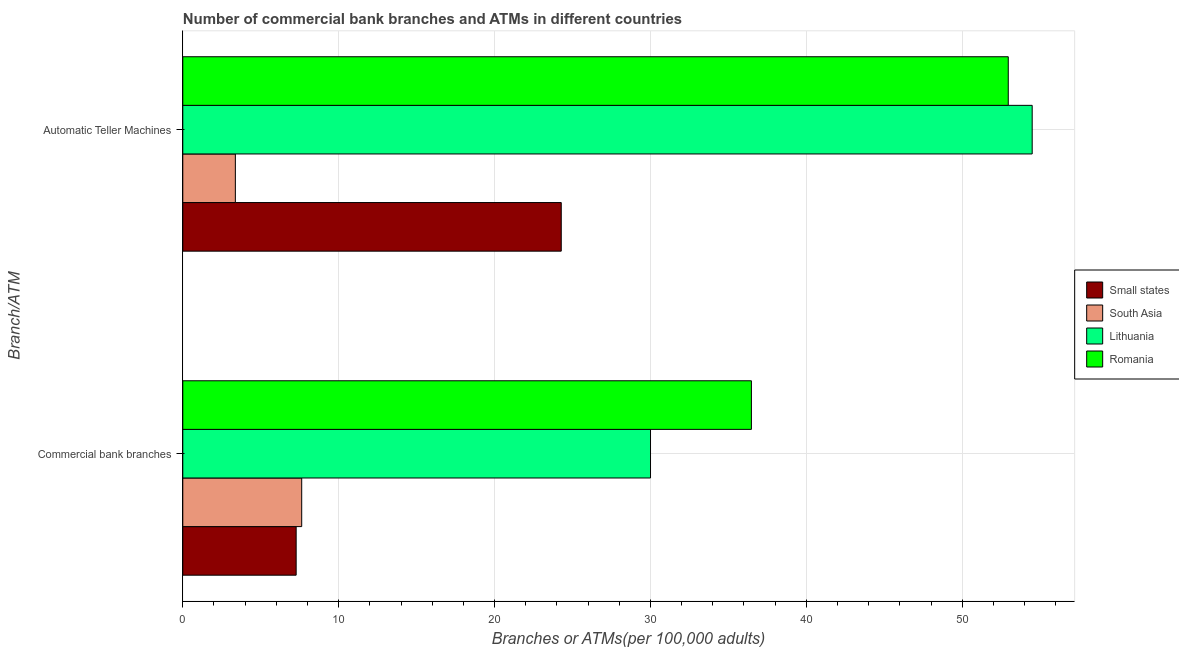How many groups of bars are there?
Make the answer very short. 2. Are the number of bars per tick equal to the number of legend labels?
Offer a very short reply. Yes. Are the number of bars on each tick of the Y-axis equal?
Offer a terse response. Yes. How many bars are there on the 2nd tick from the top?
Offer a terse response. 4. How many bars are there on the 2nd tick from the bottom?
Offer a terse response. 4. What is the label of the 1st group of bars from the top?
Offer a very short reply. Automatic Teller Machines. What is the number of commercal bank branches in Small states?
Make the answer very short. 7.27. Across all countries, what is the maximum number of atms?
Offer a very short reply. 54.49. Across all countries, what is the minimum number of commercal bank branches?
Your response must be concise. 7.27. In which country was the number of commercal bank branches maximum?
Offer a terse response. Romania. In which country was the number of atms minimum?
Provide a short and direct response. South Asia. What is the total number of commercal bank branches in the graph?
Provide a succinct answer. 81.38. What is the difference between the number of commercal bank branches in Small states and that in South Asia?
Your answer should be very brief. -0.36. What is the difference between the number of atms in South Asia and the number of commercal bank branches in Romania?
Your answer should be very brief. -33.1. What is the average number of atms per country?
Provide a short and direct response. 33.77. What is the difference between the number of atms and number of commercal bank branches in Small states?
Your response must be concise. 17. In how many countries, is the number of atms greater than 26 ?
Provide a succinct answer. 2. What is the ratio of the number of commercal bank branches in Lithuania to that in Small states?
Your answer should be very brief. 4.13. Is the number of commercal bank branches in Small states less than that in South Asia?
Your response must be concise. Yes. In how many countries, is the number of atms greater than the average number of atms taken over all countries?
Give a very brief answer. 2. What does the 1st bar from the top in Commercial bank branches represents?
Provide a short and direct response. Romania. What does the 2nd bar from the bottom in Commercial bank branches represents?
Your answer should be compact. South Asia. How many bars are there?
Give a very brief answer. 8. Are all the bars in the graph horizontal?
Give a very brief answer. Yes. What is the difference between two consecutive major ticks on the X-axis?
Offer a very short reply. 10. Are the values on the major ticks of X-axis written in scientific E-notation?
Ensure brevity in your answer.  No. Where does the legend appear in the graph?
Make the answer very short. Center right. How are the legend labels stacked?
Keep it short and to the point. Vertical. What is the title of the graph?
Offer a very short reply. Number of commercial bank branches and ATMs in different countries. What is the label or title of the X-axis?
Keep it short and to the point. Branches or ATMs(per 100,0 adults). What is the label or title of the Y-axis?
Provide a succinct answer. Branch/ATM. What is the Branches or ATMs(per 100,000 adults) of Small states in Commercial bank branches?
Offer a terse response. 7.27. What is the Branches or ATMs(per 100,000 adults) in South Asia in Commercial bank branches?
Your answer should be very brief. 7.63. What is the Branches or ATMs(per 100,000 adults) of Lithuania in Commercial bank branches?
Ensure brevity in your answer.  30. What is the Branches or ATMs(per 100,000 adults) of Romania in Commercial bank branches?
Offer a terse response. 36.48. What is the Branches or ATMs(per 100,000 adults) in Small states in Automatic Teller Machines?
Provide a short and direct response. 24.28. What is the Branches or ATMs(per 100,000 adults) in South Asia in Automatic Teller Machines?
Provide a succinct answer. 3.37. What is the Branches or ATMs(per 100,000 adults) in Lithuania in Automatic Teller Machines?
Keep it short and to the point. 54.49. What is the Branches or ATMs(per 100,000 adults) of Romania in Automatic Teller Machines?
Your answer should be compact. 52.95. Across all Branch/ATM, what is the maximum Branches or ATMs(per 100,000 adults) of Small states?
Keep it short and to the point. 24.28. Across all Branch/ATM, what is the maximum Branches or ATMs(per 100,000 adults) of South Asia?
Your response must be concise. 7.63. Across all Branch/ATM, what is the maximum Branches or ATMs(per 100,000 adults) of Lithuania?
Provide a short and direct response. 54.49. Across all Branch/ATM, what is the maximum Branches or ATMs(per 100,000 adults) in Romania?
Ensure brevity in your answer.  52.95. Across all Branch/ATM, what is the minimum Branches or ATMs(per 100,000 adults) of Small states?
Ensure brevity in your answer.  7.27. Across all Branch/ATM, what is the minimum Branches or ATMs(per 100,000 adults) of South Asia?
Provide a succinct answer. 3.37. Across all Branch/ATM, what is the minimum Branches or ATMs(per 100,000 adults) in Lithuania?
Your response must be concise. 30. Across all Branch/ATM, what is the minimum Branches or ATMs(per 100,000 adults) of Romania?
Make the answer very short. 36.48. What is the total Branches or ATMs(per 100,000 adults) in Small states in the graph?
Offer a very short reply. 31.55. What is the total Branches or ATMs(per 100,000 adults) in South Asia in the graph?
Give a very brief answer. 11. What is the total Branches or ATMs(per 100,000 adults) of Lithuania in the graph?
Offer a terse response. 84.49. What is the total Branches or ATMs(per 100,000 adults) of Romania in the graph?
Keep it short and to the point. 89.43. What is the difference between the Branches or ATMs(per 100,000 adults) of Small states in Commercial bank branches and that in Automatic Teller Machines?
Offer a very short reply. -17. What is the difference between the Branches or ATMs(per 100,000 adults) of South Asia in Commercial bank branches and that in Automatic Teller Machines?
Offer a terse response. 4.26. What is the difference between the Branches or ATMs(per 100,000 adults) of Lithuania in Commercial bank branches and that in Automatic Teller Machines?
Your answer should be very brief. -24.48. What is the difference between the Branches or ATMs(per 100,000 adults) of Romania in Commercial bank branches and that in Automatic Teller Machines?
Provide a short and direct response. -16.48. What is the difference between the Branches or ATMs(per 100,000 adults) of Small states in Commercial bank branches and the Branches or ATMs(per 100,000 adults) of South Asia in Automatic Teller Machines?
Ensure brevity in your answer.  3.9. What is the difference between the Branches or ATMs(per 100,000 adults) of Small states in Commercial bank branches and the Branches or ATMs(per 100,000 adults) of Lithuania in Automatic Teller Machines?
Your answer should be compact. -47.22. What is the difference between the Branches or ATMs(per 100,000 adults) of Small states in Commercial bank branches and the Branches or ATMs(per 100,000 adults) of Romania in Automatic Teller Machines?
Your response must be concise. -45.68. What is the difference between the Branches or ATMs(per 100,000 adults) in South Asia in Commercial bank branches and the Branches or ATMs(per 100,000 adults) in Lithuania in Automatic Teller Machines?
Offer a very short reply. -46.86. What is the difference between the Branches or ATMs(per 100,000 adults) in South Asia in Commercial bank branches and the Branches or ATMs(per 100,000 adults) in Romania in Automatic Teller Machines?
Provide a short and direct response. -45.33. What is the difference between the Branches or ATMs(per 100,000 adults) of Lithuania in Commercial bank branches and the Branches or ATMs(per 100,000 adults) of Romania in Automatic Teller Machines?
Keep it short and to the point. -22.95. What is the average Branches or ATMs(per 100,000 adults) in Small states per Branch/ATM?
Ensure brevity in your answer.  15.77. What is the average Branches or ATMs(per 100,000 adults) of South Asia per Branch/ATM?
Offer a very short reply. 5.5. What is the average Branches or ATMs(per 100,000 adults) in Lithuania per Branch/ATM?
Make the answer very short. 42.25. What is the average Branches or ATMs(per 100,000 adults) in Romania per Branch/ATM?
Provide a short and direct response. 44.71. What is the difference between the Branches or ATMs(per 100,000 adults) of Small states and Branches or ATMs(per 100,000 adults) of South Asia in Commercial bank branches?
Your answer should be very brief. -0.36. What is the difference between the Branches or ATMs(per 100,000 adults) in Small states and Branches or ATMs(per 100,000 adults) in Lithuania in Commercial bank branches?
Keep it short and to the point. -22.73. What is the difference between the Branches or ATMs(per 100,000 adults) of Small states and Branches or ATMs(per 100,000 adults) of Romania in Commercial bank branches?
Make the answer very short. -29.2. What is the difference between the Branches or ATMs(per 100,000 adults) of South Asia and Branches or ATMs(per 100,000 adults) of Lithuania in Commercial bank branches?
Provide a short and direct response. -22.38. What is the difference between the Branches or ATMs(per 100,000 adults) in South Asia and Branches or ATMs(per 100,000 adults) in Romania in Commercial bank branches?
Ensure brevity in your answer.  -28.85. What is the difference between the Branches or ATMs(per 100,000 adults) of Lithuania and Branches or ATMs(per 100,000 adults) of Romania in Commercial bank branches?
Provide a succinct answer. -6.47. What is the difference between the Branches or ATMs(per 100,000 adults) of Small states and Branches or ATMs(per 100,000 adults) of South Asia in Automatic Teller Machines?
Provide a succinct answer. 20.9. What is the difference between the Branches or ATMs(per 100,000 adults) of Small states and Branches or ATMs(per 100,000 adults) of Lithuania in Automatic Teller Machines?
Provide a succinct answer. -30.21. What is the difference between the Branches or ATMs(per 100,000 adults) in Small states and Branches or ATMs(per 100,000 adults) in Romania in Automatic Teller Machines?
Ensure brevity in your answer.  -28.68. What is the difference between the Branches or ATMs(per 100,000 adults) of South Asia and Branches or ATMs(per 100,000 adults) of Lithuania in Automatic Teller Machines?
Your answer should be compact. -51.12. What is the difference between the Branches or ATMs(per 100,000 adults) of South Asia and Branches or ATMs(per 100,000 adults) of Romania in Automatic Teller Machines?
Make the answer very short. -49.58. What is the difference between the Branches or ATMs(per 100,000 adults) of Lithuania and Branches or ATMs(per 100,000 adults) of Romania in Automatic Teller Machines?
Make the answer very short. 1.53. What is the ratio of the Branches or ATMs(per 100,000 adults) in Small states in Commercial bank branches to that in Automatic Teller Machines?
Offer a terse response. 0.3. What is the ratio of the Branches or ATMs(per 100,000 adults) of South Asia in Commercial bank branches to that in Automatic Teller Machines?
Ensure brevity in your answer.  2.26. What is the ratio of the Branches or ATMs(per 100,000 adults) in Lithuania in Commercial bank branches to that in Automatic Teller Machines?
Offer a terse response. 0.55. What is the ratio of the Branches or ATMs(per 100,000 adults) in Romania in Commercial bank branches to that in Automatic Teller Machines?
Give a very brief answer. 0.69. What is the difference between the highest and the second highest Branches or ATMs(per 100,000 adults) in Small states?
Offer a terse response. 17. What is the difference between the highest and the second highest Branches or ATMs(per 100,000 adults) of South Asia?
Make the answer very short. 4.26. What is the difference between the highest and the second highest Branches or ATMs(per 100,000 adults) in Lithuania?
Keep it short and to the point. 24.48. What is the difference between the highest and the second highest Branches or ATMs(per 100,000 adults) of Romania?
Make the answer very short. 16.48. What is the difference between the highest and the lowest Branches or ATMs(per 100,000 adults) in Small states?
Offer a terse response. 17. What is the difference between the highest and the lowest Branches or ATMs(per 100,000 adults) in South Asia?
Your response must be concise. 4.26. What is the difference between the highest and the lowest Branches or ATMs(per 100,000 adults) in Lithuania?
Your answer should be very brief. 24.48. What is the difference between the highest and the lowest Branches or ATMs(per 100,000 adults) in Romania?
Give a very brief answer. 16.48. 